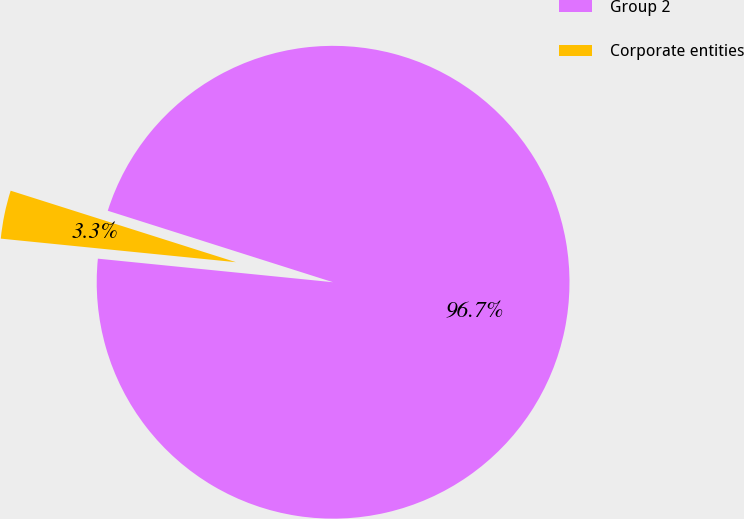<chart> <loc_0><loc_0><loc_500><loc_500><pie_chart><fcel>Group 2<fcel>Corporate entities<nl><fcel>96.7%<fcel>3.3%<nl></chart> 